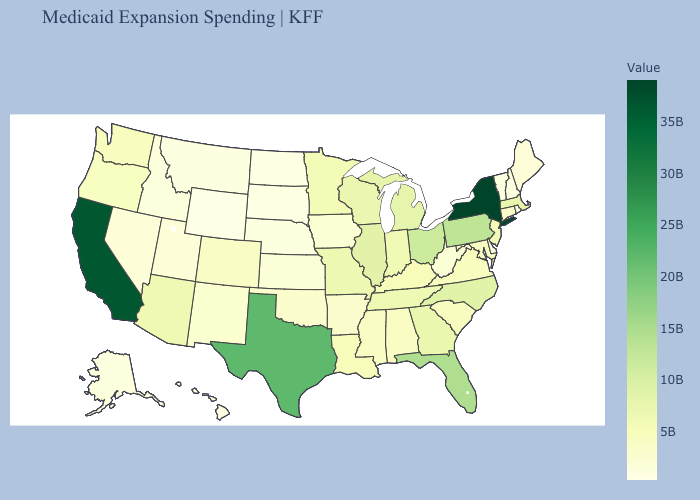Which states have the lowest value in the MidWest?
Answer briefly. North Dakota. Among the states that border New Hampshire , which have the highest value?
Be succinct. Massachusetts. Does Wyoming have the lowest value in the West?
Quick response, please. Yes. Among the states that border North Dakota , does Minnesota have the lowest value?
Short answer required. No. Among the states that border New Mexico , which have the highest value?
Write a very short answer. Texas. 